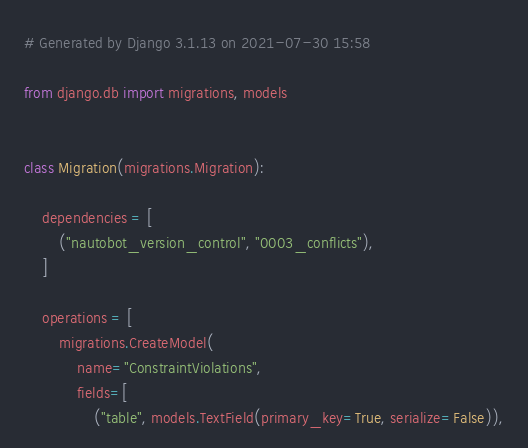<code> <loc_0><loc_0><loc_500><loc_500><_Python_># Generated by Django 3.1.13 on 2021-07-30 15:58

from django.db import migrations, models


class Migration(migrations.Migration):

    dependencies = [
        ("nautobot_version_control", "0003_conflicts"),
    ]

    operations = [
        migrations.CreateModel(
            name="ConstraintViolations",
            fields=[
                ("table", models.TextField(primary_key=True, serialize=False)),</code> 